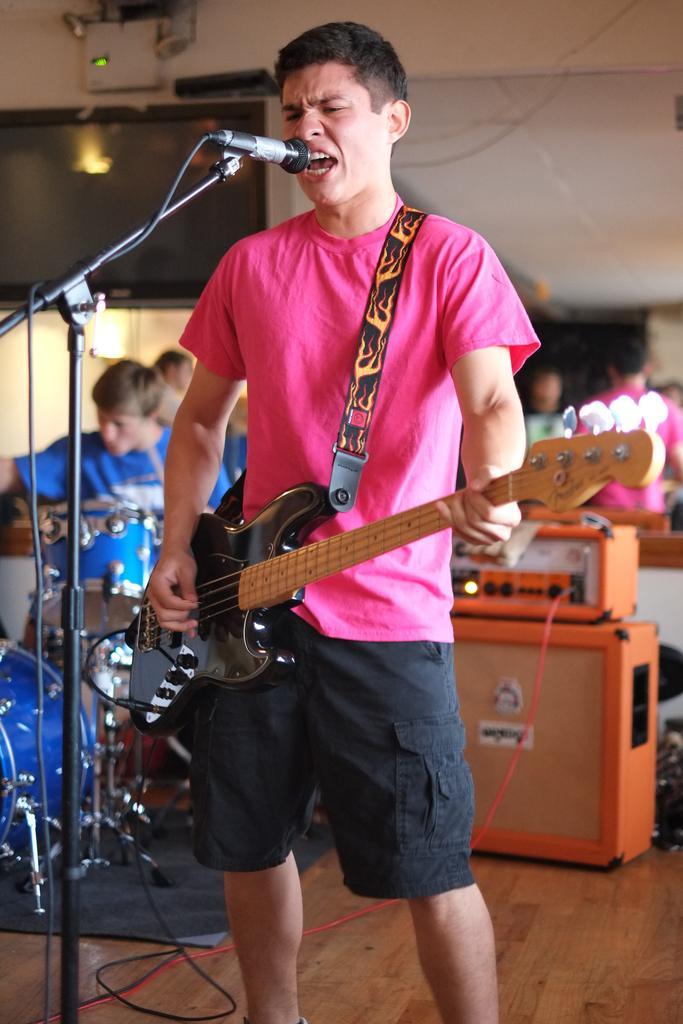Could you give a brief overview of what you see in this image? In this image, we can see a person is standing and playing a guitar. He is singing in-front of a microphone with stand and wire. Background we can see few people, musical instruments, machines, objects, wire. Here there is a wall. At the bottom, there is a wooden floor. 